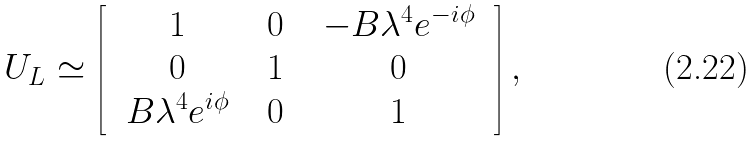<formula> <loc_0><loc_0><loc_500><loc_500>U _ { L } \simeq \left [ \begin{array} { c c c } \ 1 \ & \ 0 \ & \ - B \lambda ^ { 4 } e ^ { - i \phi } \ \\ \ 0 \ & \ 1 \ & \ 0 \ \\ \ B \lambda ^ { 4 } e ^ { i \phi } \ & \ 0 \ & \ 1 \ \end{array} \right ] ,</formula> 